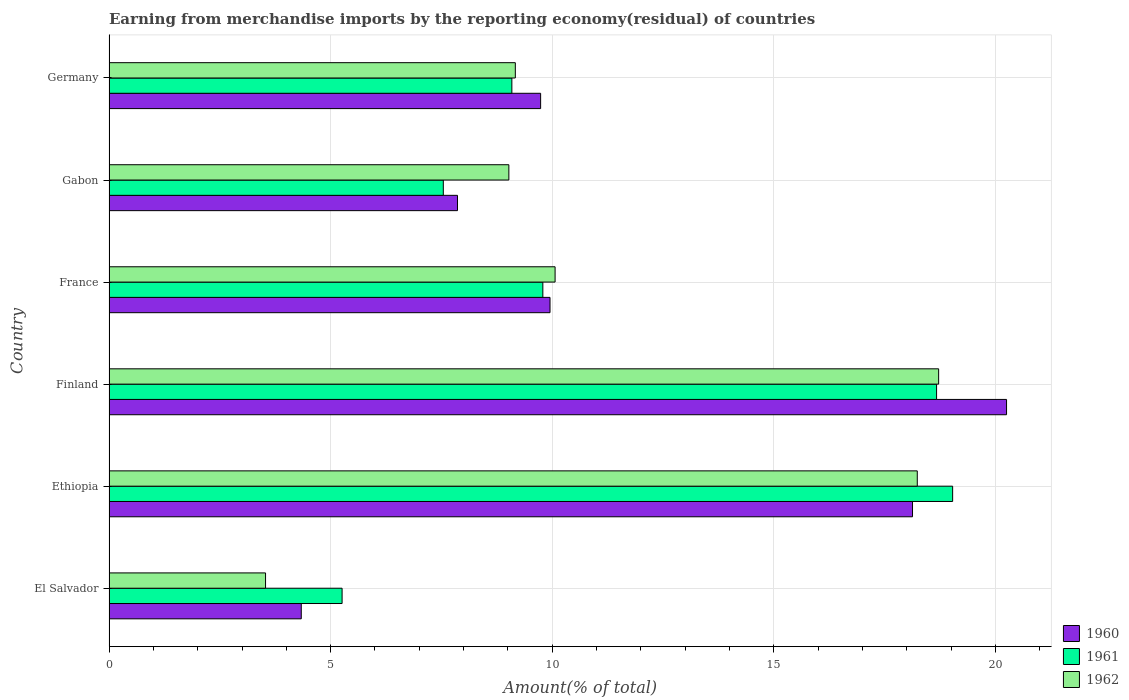How many different coloured bars are there?
Provide a succinct answer. 3. Are the number of bars per tick equal to the number of legend labels?
Offer a terse response. Yes. Are the number of bars on each tick of the Y-axis equal?
Keep it short and to the point. Yes. How many bars are there on the 2nd tick from the top?
Provide a short and direct response. 3. How many bars are there on the 4th tick from the bottom?
Keep it short and to the point. 3. What is the label of the 6th group of bars from the top?
Provide a succinct answer. El Salvador. In how many cases, is the number of bars for a given country not equal to the number of legend labels?
Ensure brevity in your answer.  0. What is the percentage of amount earned from merchandise imports in 1962 in Gabon?
Give a very brief answer. 9.02. Across all countries, what is the maximum percentage of amount earned from merchandise imports in 1960?
Your response must be concise. 20.25. Across all countries, what is the minimum percentage of amount earned from merchandise imports in 1961?
Provide a short and direct response. 5.26. In which country was the percentage of amount earned from merchandise imports in 1961 maximum?
Make the answer very short. Ethiopia. In which country was the percentage of amount earned from merchandise imports in 1960 minimum?
Your answer should be compact. El Salvador. What is the total percentage of amount earned from merchandise imports in 1962 in the graph?
Your answer should be very brief. 68.73. What is the difference between the percentage of amount earned from merchandise imports in 1960 in El Salvador and that in Finland?
Your response must be concise. -15.91. What is the difference between the percentage of amount earned from merchandise imports in 1961 in Gabon and the percentage of amount earned from merchandise imports in 1962 in France?
Give a very brief answer. -2.52. What is the average percentage of amount earned from merchandise imports in 1962 per country?
Your response must be concise. 11.46. What is the difference between the percentage of amount earned from merchandise imports in 1962 and percentage of amount earned from merchandise imports in 1960 in Finland?
Keep it short and to the point. -1.53. What is the ratio of the percentage of amount earned from merchandise imports in 1962 in El Salvador to that in Finland?
Ensure brevity in your answer.  0.19. Is the percentage of amount earned from merchandise imports in 1960 in Gabon less than that in Germany?
Keep it short and to the point. Yes. Is the difference between the percentage of amount earned from merchandise imports in 1962 in El Salvador and Finland greater than the difference between the percentage of amount earned from merchandise imports in 1960 in El Salvador and Finland?
Provide a succinct answer. Yes. What is the difference between the highest and the second highest percentage of amount earned from merchandise imports in 1961?
Make the answer very short. 0.36. What is the difference between the highest and the lowest percentage of amount earned from merchandise imports in 1961?
Keep it short and to the point. 13.77. In how many countries, is the percentage of amount earned from merchandise imports in 1960 greater than the average percentage of amount earned from merchandise imports in 1960 taken over all countries?
Your answer should be compact. 2. Is the sum of the percentage of amount earned from merchandise imports in 1962 in El Salvador and Finland greater than the maximum percentage of amount earned from merchandise imports in 1960 across all countries?
Provide a short and direct response. Yes. What does the 3rd bar from the top in Ethiopia represents?
Provide a succinct answer. 1960. Are the values on the major ticks of X-axis written in scientific E-notation?
Your answer should be very brief. No. What is the title of the graph?
Ensure brevity in your answer.  Earning from merchandise imports by the reporting economy(residual) of countries. What is the label or title of the X-axis?
Ensure brevity in your answer.  Amount(% of total). What is the Amount(% of total) in 1960 in El Salvador?
Offer a terse response. 4.34. What is the Amount(% of total) in 1961 in El Salvador?
Offer a very short reply. 5.26. What is the Amount(% of total) in 1962 in El Salvador?
Provide a succinct answer. 3.53. What is the Amount(% of total) in 1960 in Ethiopia?
Your answer should be compact. 18.13. What is the Amount(% of total) of 1961 in Ethiopia?
Provide a short and direct response. 19.03. What is the Amount(% of total) of 1962 in Ethiopia?
Your answer should be compact. 18.23. What is the Amount(% of total) in 1960 in Finland?
Offer a terse response. 20.25. What is the Amount(% of total) in 1961 in Finland?
Your answer should be very brief. 18.67. What is the Amount(% of total) in 1962 in Finland?
Provide a short and direct response. 18.72. What is the Amount(% of total) of 1960 in France?
Offer a terse response. 9.95. What is the Amount(% of total) of 1961 in France?
Offer a very short reply. 9.79. What is the Amount(% of total) of 1962 in France?
Your answer should be compact. 10.06. What is the Amount(% of total) in 1960 in Gabon?
Provide a short and direct response. 7.86. What is the Amount(% of total) in 1961 in Gabon?
Make the answer very short. 7.54. What is the Amount(% of total) of 1962 in Gabon?
Provide a short and direct response. 9.02. What is the Amount(% of total) in 1960 in Germany?
Provide a short and direct response. 9.74. What is the Amount(% of total) of 1961 in Germany?
Offer a very short reply. 9.09. What is the Amount(% of total) in 1962 in Germany?
Provide a succinct answer. 9.17. Across all countries, what is the maximum Amount(% of total) of 1960?
Give a very brief answer. 20.25. Across all countries, what is the maximum Amount(% of total) in 1961?
Make the answer very short. 19.03. Across all countries, what is the maximum Amount(% of total) of 1962?
Your response must be concise. 18.72. Across all countries, what is the minimum Amount(% of total) in 1960?
Keep it short and to the point. 4.34. Across all countries, what is the minimum Amount(% of total) in 1961?
Your answer should be very brief. 5.26. Across all countries, what is the minimum Amount(% of total) of 1962?
Provide a short and direct response. 3.53. What is the total Amount(% of total) in 1960 in the graph?
Your response must be concise. 70.26. What is the total Amount(% of total) in 1961 in the graph?
Your response must be concise. 69.38. What is the total Amount(% of total) in 1962 in the graph?
Your answer should be very brief. 68.73. What is the difference between the Amount(% of total) of 1960 in El Salvador and that in Ethiopia?
Offer a very short reply. -13.79. What is the difference between the Amount(% of total) in 1961 in El Salvador and that in Ethiopia?
Provide a short and direct response. -13.77. What is the difference between the Amount(% of total) of 1962 in El Salvador and that in Ethiopia?
Your answer should be very brief. -14.7. What is the difference between the Amount(% of total) of 1960 in El Salvador and that in Finland?
Offer a very short reply. -15.91. What is the difference between the Amount(% of total) of 1961 in El Salvador and that in Finland?
Your answer should be very brief. -13.41. What is the difference between the Amount(% of total) of 1962 in El Salvador and that in Finland?
Your answer should be very brief. -15.19. What is the difference between the Amount(% of total) of 1960 in El Salvador and that in France?
Keep it short and to the point. -5.61. What is the difference between the Amount(% of total) in 1961 in El Salvador and that in France?
Your answer should be very brief. -4.53. What is the difference between the Amount(% of total) of 1962 in El Salvador and that in France?
Give a very brief answer. -6.53. What is the difference between the Amount(% of total) of 1960 in El Salvador and that in Gabon?
Your answer should be compact. -3.52. What is the difference between the Amount(% of total) in 1961 in El Salvador and that in Gabon?
Your answer should be very brief. -2.28. What is the difference between the Amount(% of total) of 1962 in El Salvador and that in Gabon?
Offer a terse response. -5.49. What is the difference between the Amount(% of total) of 1960 in El Salvador and that in Germany?
Give a very brief answer. -5.4. What is the difference between the Amount(% of total) of 1961 in El Salvador and that in Germany?
Ensure brevity in your answer.  -3.83. What is the difference between the Amount(% of total) in 1962 in El Salvador and that in Germany?
Offer a terse response. -5.64. What is the difference between the Amount(% of total) in 1960 in Ethiopia and that in Finland?
Provide a succinct answer. -2.12. What is the difference between the Amount(% of total) of 1961 in Ethiopia and that in Finland?
Your answer should be very brief. 0.36. What is the difference between the Amount(% of total) of 1962 in Ethiopia and that in Finland?
Offer a very short reply. -0.48. What is the difference between the Amount(% of total) in 1960 in Ethiopia and that in France?
Give a very brief answer. 8.18. What is the difference between the Amount(% of total) in 1961 in Ethiopia and that in France?
Provide a short and direct response. 9.24. What is the difference between the Amount(% of total) in 1962 in Ethiopia and that in France?
Your response must be concise. 8.17. What is the difference between the Amount(% of total) in 1960 in Ethiopia and that in Gabon?
Provide a short and direct response. 10.27. What is the difference between the Amount(% of total) of 1961 in Ethiopia and that in Gabon?
Your answer should be compact. 11.49. What is the difference between the Amount(% of total) of 1962 in Ethiopia and that in Gabon?
Keep it short and to the point. 9.21. What is the difference between the Amount(% of total) of 1960 in Ethiopia and that in Germany?
Make the answer very short. 8.39. What is the difference between the Amount(% of total) in 1961 in Ethiopia and that in Germany?
Offer a very short reply. 9.94. What is the difference between the Amount(% of total) of 1962 in Ethiopia and that in Germany?
Make the answer very short. 9.07. What is the difference between the Amount(% of total) in 1960 in Finland and that in France?
Keep it short and to the point. 10.3. What is the difference between the Amount(% of total) in 1961 in Finland and that in France?
Offer a terse response. 8.88. What is the difference between the Amount(% of total) in 1962 in Finland and that in France?
Your response must be concise. 8.65. What is the difference between the Amount(% of total) of 1960 in Finland and that in Gabon?
Your response must be concise. 12.39. What is the difference between the Amount(% of total) of 1961 in Finland and that in Gabon?
Give a very brief answer. 11.13. What is the difference between the Amount(% of total) in 1962 in Finland and that in Gabon?
Make the answer very short. 9.7. What is the difference between the Amount(% of total) of 1960 in Finland and that in Germany?
Give a very brief answer. 10.51. What is the difference between the Amount(% of total) of 1961 in Finland and that in Germany?
Your answer should be compact. 9.58. What is the difference between the Amount(% of total) in 1962 in Finland and that in Germany?
Your answer should be very brief. 9.55. What is the difference between the Amount(% of total) in 1960 in France and that in Gabon?
Give a very brief answer. 2.09. What is the difference between the Amount(% of total) of 1961 in France and that in Gabon?
Your answer should be compact. 2.25. What is the difference between the Amount(% of total) in 1962 in France and that in Gabon?
Give a very brief answer. 1.04. What is the difference between the Amount(% of total) of 1960 in France and that in Germany?
Keep it short and to the point. 0.21. What is the difference between the Amount(% of total) of 1961 in France and that in Germany?
Your response must be concise. 0.7. What is the difference between the Amount(% of total) in 1962 in France and that in Germany?
Ensure brevity in your answer.  0.9. What is the difference between the Amount(% of total) in 1960 in Gabon and that in Germany?
Provide a short and direct response. -1.88. What is the difference between the Amount(% of total) in 1961 in Gabon and that in Germany?
Offer a very short reply. -1.55. What is the difference between the Amount(% of total) of 1962 in Gabon and that in Germany?
Offer a terse response. -0.15. What is the difference between the Amount(% of total) of 1960 in El Salvador and the Amount(% of total) of 1961 in Ethiopia?
Provide a short and direct response. -14.7. What is the difference between the Amount(% of total) in 1960 in El Salvador and the Amount(% of total) in 1962 in Ethiopia?
Offer a terse response. -13.9. What is the difference between the Amount(% of total) in 1961 in El Salvador and the Amount(% of total) in 1962 in Ethiopia?
Your answer should be very brief. -12.98. What is the difference between the Amount(% of total) of 1960 in El Salvador and the Amount(% of total) of 1961 in Finland?
Your response must be concise. -14.33. What is the difference between the Amount(% of total) in 1960 in El Salvador and the Amount(% of total) in 1962 in Finland?
Offer a very short reply. -14.38. What is the difference between the Amount(% of total) of 1961 in El Salvador and the Amount(% of total) of 1962 in Finland?
Offer a very short reply. -13.46. What is the difference between the Amount(% of total) in 1960 in El Salvador and the Amount(% of total) in 1961 in France?
Give a very brief answer. -5.45. What is the difference between the Amount(% of total) of 1960 in El Salvador and the Amount(% of total) of 1962 in France?
Give a very brief answer. -5.73. What is the difference between the Amount(% of total) in 1961 in El Salvador and the Amount(% of total) in 1962 in France?
Offer a terse response. -4.81. What is the difference between the Amount(% of total) of 1960 in El Salvador and the Amount(% of total) of 1961 in Gabon?
Your response must be concise. -3.2. What is the difference between the Amount(% of total) in 1960 in El Salvador and the Amount(% of total) in 1962 in Gabon?
Give a very brief answer. -4.68. What is the difference between the Amount(% of total) of 1961 in El Salvador and the Amount(% of total) of 1962 in Gabon?
Keep it short and to the point. -3.76. What is the difference between the Amount(% of total) of 1960 in El Salvador and the Amount(% of total) of 1961 in Germany?
Your answer should be very brief. -4.75. What is the difference between the Amount(% of total) of 1960 in El Salvador and the Amount(% of total) of 1962 in Germany?
Your answer should be very brief. -4.83. What is the difference between the Amount(% of total) of 1961 in El Salvador and the Amount(% of total) of 1962 in Germany?
Make the answer very short. -3.91. What is the difference between the Amount(% of total) in 1960 in Ethiopia and the Amount(% of total) in 1961 in Finland?
Your response must be concise. -0.54. What is the difference between the Amount(% of total) of 1960 in Ethiopia and the Amount(% of total) of 1962 in Finland?
Offer a terse response. -0.59. What is the difference between the Amount(% of total) in 1961 in Ethiopia and the Amount(% of total) in 1962 in Finland?
Provide a short and direct response. 0.32. What is the difference between the Amount(% of total) of 1960 in Ethiopia and the Amount(% of total) of 1961 in France?
Your answer should be very brief. 8.34. What is the difference between the Amount(% of total) of 1960 in Ethiopia and the Amount(% of total) of 1962 in France?
Ensure brevity in your answer.  8.06. What is the difference between the Amount(% of total) of 1961 in Ethiopia and the Amount(% of total) of 1962 in France?
Keep it short and to the point. 8.97. What is the difference between the Amount(% of total) in 1960 in Ethiopia and the Amount(% of total) in 1961 in Gabon?
Ensure brevity in your answer.  10.59. What is the difference between the Amount(% of total) of 1960 in Ethiopia and the Amount(% of total) of 1962 in Gabon?
Your response must be concise. 9.11. What is the difference between the Amount(% of total) of 1961 in Ethiopia and the Amount(% of total) of 1962 in Gabon?
Offer a very short reply. 10.01. What is the difference between the Amount(% of total) in 1960 in Ethiopia and the Amount(% of total) in 1961 in Germany?
Your answer should be very brief. 9.04. What is the difference between the Amount(% of total) in 1960 in Ethiopia and the Amount(% of total) in 1962 in Germany?
Provide a short and direct response. 8.96. What is the difference between the Amount(% of total) in 1961 in Ethiopia and the Amount(% of total) in 1962 in Germany?
Keep it short and to the point. 9.87. What is the difference between the Amount(% of total) of 1960 in Finland and the Amount(% of total) of 1961 in France?
Ensure brevity in your answer.  10.46. What is the difference between the Amount(% of total) in 1960 in Finland and the Amount(% of total) in 1962 in France?
Your response must be concise. 10.19. What is the difference between the Amount(% of total) of 1961 in Finland and the Amount(% of total) of 1962 in France?
Offer a terse response. 8.61. What is the difference between the Amount(% of total) of 1960 in Finland and the Amount(% of total) of 1961 in Gabon?
Ensure brevity in your answer.  12.71. What is the difference between the Amount(% of total) of 1960 in Finland and the Amount(% of total) of 1962 in Gabon?
Keep it short and to the point. 11.23. What is the difference between the Amount(% of total) in 1961 in Finland and the Amount(% of total) in 1962 in Gabon?
Offer a terse response. 9.65. What is the difference between the Amount(% of total) of 1960 in Finland and the Amount(% of total) of 1961 in Germany?
Provide a short and direct response. 11.16. What is the difference between the Amount(% of total) in 1960 in Finland and the Amount(% of total) in 1962 in Germany?
Your answer should be compact. 11.08. What is the difference between the Amount(% of total) of 1961 in Finland and the Amount(% of total) of 1962 in Germany?
Offer a very short reply. 9.5. What is the difference between the Amount(% of total) in 1960 in France and the Amount(% of total) in 1961 in Gabon?
Your response must be concise. 2.41. What is the difference between the Amount(% of total) in 1960 in France and the Amount(% of total) in 1962 in Gabon?
Make the answer very short. 0.93. What is the difference between the Amount(% of total) of 1961 in France and the Amount(% of total) of 1962 in Gabon?
Keep it short and to the point. 0.77. What is the difference between the Amount(% of total) of 1960 in France and the Amount(% of total) of 1961 in Germany?
Provide a succinct answer. 0.86. What is the difference between the Amount(% of total) in 1960 in France and the Amount(% of total) in 1962 in Germany?
Make the answer very short. 0.78. What is the difference between the Amount(% of total) of 1961 in France and the Amount(% of total) of 1962 in Germany?
Your response must be concise. 0.62. What is the difference between the Amount(% of total) of 1960 in Gabon and the Amount(% of total) of 1961 in Germany?
Provide a succinct answer. -1.23. What is the difference between the Amount(% of total) of 1960 in Gabon and the Amount(% of total) of 1962 in Germany?
Ensure brevity in your answer.  -1.3. What is the difference between the Amount(% of total) in 1961 in Gabon and the Amount(% of total) in 1962 in Germany?
Ensure brevity in your answer.  -1.62. What is the average Amount(% of total) of 1960 per country?
Your answer should be compact. 11.71. What is the average Amount(% of total) of 1961 per country?
Keep it short and to the point. 11.56. What is the average Amount(% of total) of 1962 per country?
Offer a very short reply. 11.46. What is the difference between the Amount(% of total) of 1960 and Amount(% of total) of 1961 in El Salvador?
Your answer should be very brief. -0.92. What is the difference between the Amount(% of total) of 1960 and Amount(% of total) of 1962 in El Salvador?
Your answer should be very brief. 0.81. What is the difference between the Amount(% of total) in 1961 and Amount(% of total) in 1962 in El Salvador?
Make the answer very short. 1.73. What is the difference between the Amount(% of total) of 1960 and Amount(% of total) of 1961 in Ethiopia?
Ensure brevity in your answer.  -0.91. What is the difference between the Amount(% of total) of 1960 and Amount(% of total) of 1962 in Ethiopia?
Provide a succinct answer. -0.11. What is the difference between the Amount(% of total) of 1961 and Amount(% of total) of 1962 in Ethiopia?
Your answer should be very brief. 0.8. What is the difference between the Amount(% of total) of 1960 and Amount(% of total) of 1961 in Finland?
Provide a succinct answer. 1.58. What is the difference between the Amount(% of total) in 1960 and Amount(% of total) in 1962 in Finland?
Your response must be concise. 1.53. What is the difference between the Amount(% of total) in 1961 and Amount(% of total) in 1962 in Finland?
Ensure brevity in your answer.  -0.05. What is the difference between the Amount(% of total) of 1960 and Amount(% of total) of 1961 in France?
Keep it short and to the point. 0.16. What is the difference between the Amount(% of total) of 1960 and Amount(% of total) of 1962 in France?
Your response must be concise. -0.11. What is the difference between the Amount(% of total) of 1961 and Amount(% of total) of 1962 in France?
Ensure brevity in your answer.  -0.28. What is the difference between the Amount(% of total) in 1960 and Amount(% of total) in 1961 in Gabon?
Your answer should be very brief. 0.32. What is the difference between the Amount(% of total) in 1960 and Amount(% of total) in 1962 in Gabon?
Make the answer very short. -1.16. What is the difference between the Amount(% of total) of 1961 and Amount(% of total) of 1962 in Gabon?
Your answer should be compact. -1.48. What is the difference between the Amount(% of total) in 1960 and Amount(% of total) in 1961 in Germany?
Ensure brevity in your answer.  0.65. What is the difference between the Amount(% of total) of 1960 and Amount(% of total) of 1962 in Germany?
Provide a succinct answer. 0.57. What is the difference between the Amount(% of total) of 1961 and Amount(% of total) of 1962 in Germany?
Make the answer very short. -0.08. What is the ratio of the Amount(% of total) of 1960 in El Salvador to that in Ethiopia?
Your answer should be compact. 0.24. What is the ratio of the Amount(% of total) in 1961 in El Salvador to that in Ethiopia?
Offer a terse response. 0.28. What is the ratio of the Amount(% of total) in 1962 in El Salvador to that in Ethiopia?
Make the answer very short. 0.19. What is the ratio of the Amount(% of total) of 1960 in El Salvador to that in Finland?
Keep it short and to the point. 0.21. What is the ratio of the Amount(% of total) of 1961 in El Salvador to that in Finland?
Your response must be concise. 0.28. What is the ratio of the Amount(% of total) in 1962 in El Salvador to that in Finland?
Offer a very short reply. 0.19. What is the ratio of the Amount(% of total) of 1960 in El Salvador to that in France?
Give a very brief answer. 0.44. What is the ratio of the Amount(% of total) of 1961 in El Salvador to that in France?
Give a very brief answer. 0.54. What is the ratio of the Amount(% of total) in 1962 in El Salvador to that in France?
Provide a short and direct response. 0.35. What is the ratio of the Amount(% of total) of 1960 in El Salvador to that in Gabon?
Your response must be concise. 0.55. What is the ratio of the Amount(% of total) of 1961 in El Salvador to that in Gabon?
Offer a very short reply. 0.7. What is the ratio of the Amount(% of total) in 1962 in El Salvador to that in Gabon?
Make the answer very short. 0.39. What is the ratio of the Amount(% of total) in 1960 in El Salvador to that in Germany?
Provide a short and direct response. 0.45. What is the ratio of the Amount(% of total) of 1961 in El Salvador to that in Germany?
Offer a very short reply. 0.58. What is the ratio of the Amount(% of total) of 1962 in El Salvador to that in Germany?
Offer a terse response. 0.39. What is the ratio of the Amount(% of total) of 1960 in Ethiopia to that in Finland?
Offer a terse response. 0.9. What is the ratio of the Amount(% of total) in 1961 in Ethiopia to that in Finland?
Your answer should be compact. 1.02. What is the ratio of the Amount(% of total) of 1962 in Ethiopia to that in Finland?
Keep it short and to the point. 0.97. What is the ratio of the Amount(% of total) in 1960 in Ethiopia to that in France?
Ensure brevity in your answer.  1.82. What is the ratio of the Amount(% of total) in 1961 in Ethiopia to that in France?
Your answer should be compact. 1.94. What is the ratio of the Amount(% of total) of 1962 in Ethiopia to that in France?
Offer a very short reply. 1.81. What is the ratio of the Amount(% of total) of 1960 in Ethiopia to that in Gabon?
Make the answer very short. 2.31. What is the ratio of the Amount(% of total) of 1961 in Ethiopia to that in Gabon?
Provide a short and direct response. 2.52. What is the ratio of the Amount(% of total) of 1962 in Ethiopia to that in Gabon?
Your answer should be very brief. 2.02. What is the ratio of the Amount(% of total) in 1960 in Ethiopia to that in Germany?
Ensure brevity in your answer.  1.86. What is the ratio of the Amount(% of total) in 1961 in Ethiopia to that in Germany?
Keep it short and to the point. 2.09. What is the ratio of the Amount(% of total) in 1962 in Ethiopia to that in Germany?
Your answer should be very brief. 1.99. What is the ratio of the Amount(% of total) in 1960 in Finland to that in France?
Ensure brevity in your answer.  2.04. What is the ratio of the Amount(% of total) of 1961 in Finland to that in France?
Your answer should be compact. 1.91. What is the ratio of the Amount(% of total) of 1962 in Finland to that in France?
Ensure brevity in your answer.  1.86. What is the ratio of the Amount(% of total) of 1960 in Finland to that in Gabon?
Offer a terse response. 2.58. What is the ratio of the Amount(% of total) of 1961 in Finland to that in Gabon?
Provide a succinct answer. 2.48. What is the ratio of the Amount(% of total) of 1962 in Finland to that in Gabon?
Give a very brief answer. 2.07. What is the ratio of the Amount(% of total) of 1960 in Finland to that in Germany?
Provide a short and direct response. 2.08. What is the ratio of the Amount(% of total) in 1961 in Finland to that in Germany?
Give a very brief answer. 2.05. What is the ratio of the Amount(% of total) in 1962 in Finland to that in Germany?
Your answer should be compact. 2.04. What is the ratio of the Amount(% of total) in 1960 in France to that in Gabon?
Your answer should be compact. 1.27. What is the ratio of the Amount(% of total) of 1961 in France to that in Gabon?
Provide a succinct answer. 1.3. What is the ratio of the Amount(% of total) of 1962 in France to that in Gabon?
Ensure brevity in your answer.  1.12. What is the ratio of the Amount(% of total) of 1960 in France to that in Germany?
Your answer should be compact. 1.02. What is the ratio of the Amount(% of total) in 1961 in France to that in Germany?
Offer a terse response. 1.08. What is the ratio of the Amount(% of total) in 1962 in France to that in Germany?
Ensure brevity in your answer.  1.1. What is the ratio of the Amount(% of total) in 1960 in Gabon to that in Germany?
Provide a short and direct response. 0.81. What is the ratio of the Amount(% of total) of 1961 in Gabon to that in Germany?
Your response must be concise. 0.83. What is the ratio of the Amount(% of total) of 1962 in Gabon to that in Germany?
Provide a succinct answer. 0.98. What is the difference between the highest and the second highest Amount(% of total) of 1960?
Ensure brevity in your answer.  2.12. What is the difference between the highest and the second highest Amount(% of total) in 1961?
Keep it short and to the point. 0.36. What is the difference between the highest and the second highest Amount(% of total) of 1962?
Your answer should be compact. 0.48. What is the difference between the highest and the lowest Amount(% of total) in 1960?
Give a very brief answer. 15.91. What is the difference between the highest and the lowest Amount(% of total) in 1961?
Make the answer very short. 13.77. What is the difference between the highest and the lowest Amount(% of total) in 1962?
Offer a very short reply. 15.19. 